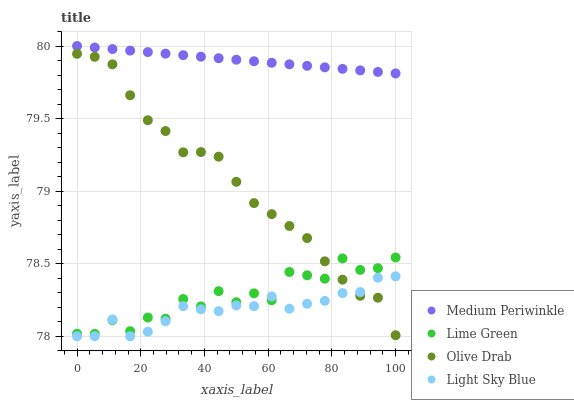Does Light Sky Blue have the minimum area under the curve?
Answer yes or no. Yes. Does Medium Periwinkle have the maximum area under the curve?
Answer yes or no. Yes. Does Medium Periwinkle have the minimum area under the curve?
Answer yes or no. No. Does Light Sky Blue have the maximum area under the curve?
Answer yes or no. No. Is Medium Periwinkle the smoothest?
Answer yes or no. Yes. Is Lime Green the roughest?
Answer yes or no. Yes. Is Light Sky Blue the smoothest?
Answer yes or no. No. Is Light Sky Blue the roughest?
Answer yes or no. No. Does Light Sky Blue have the lowest value?
Answer yes or no. Yes. Does Medium Periwinkle have the lowest value?
Answer yes or no. No. Does Medium Periwinkle have the highest value?
Answer yes or no. Yes. Does Light Sky Blue have the highest value?
Answer yes or no. No. Is Light Sky Blue less than Medium Periwinkle?
Answer yes or no. Yes. Is Medium Periwinkle greater than Lime Green?
Answer yes or no. Yes. Does Lime Green intersect Light Sky Blue?
Answer yes or no. Yes. Is Lime Green less than Light Sky Blue?
Answer yes or no. No. Is Lime Green greater than Light Sky Blue?
Answer yes or no. No. Does Light Sky Blue intersect Medium Periwinkle?
Answer yes or no. No. 